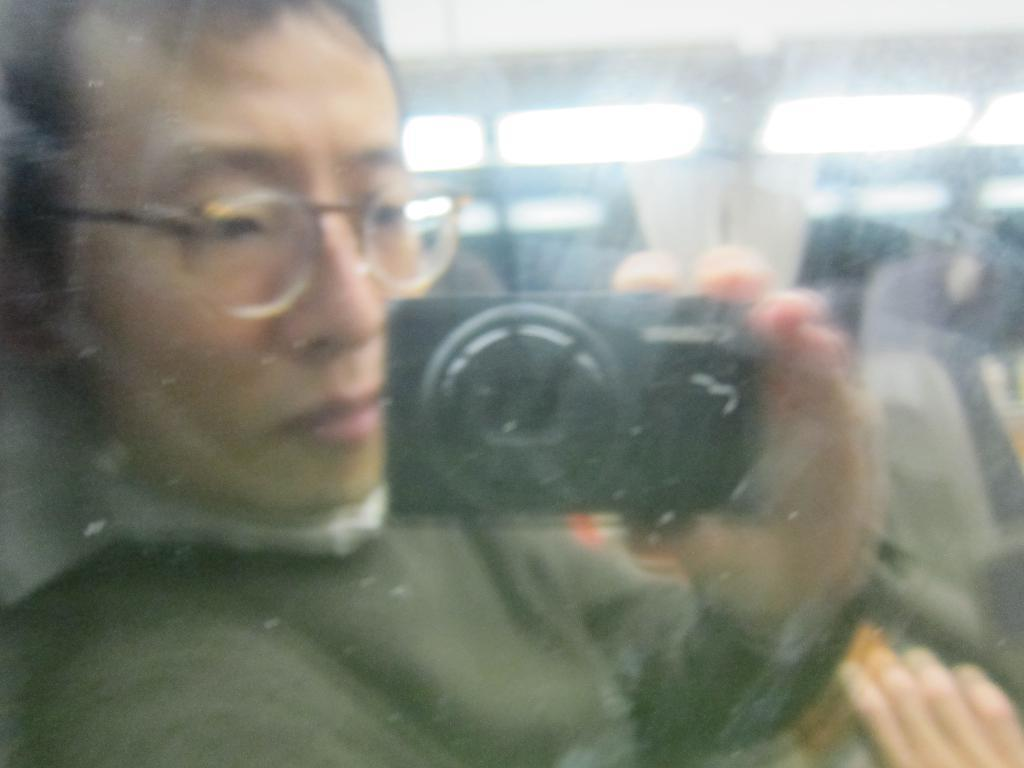Who is the main subject in the image? There is a lady in the image. What is the lady doing in the image? The lady is sitting behind glass. What is the lady holding in the image? The lady is holding a camera. What type of veil is the lady wearing in the image? There is no veil present in the image; the lady is sitting behind glass. Can you see a scarecrow in the background of the image? There is no scarecrow present in the image; the lady is sitting behind glass and holding a camera. 